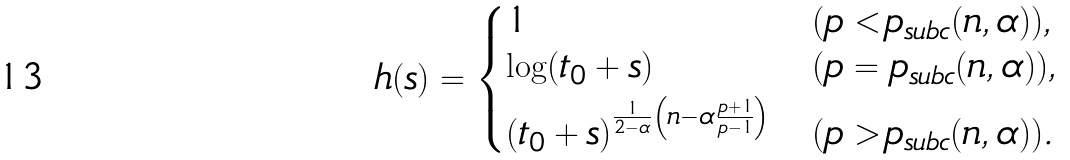Convert formula to latex. <formula><loc_0><loc_0><loc_500><loc_500>h ( s ) = \begin{dcases} 1 & ( p < p _ { s u b c } ( n , \alpha ) ) , \\ \log ( t _ { 0 } + s ) & ( p = p _ { s u b c } ( n , \alpha ) ) , \\ ( t _ { 0 } + s ) ^ { \frac { 1 } { 2 - \alpha } \left ( n - \alpha \frac { p + 1 } { p - 1 } \right ) } & ( p > p _ { s u b c } ( n , \alpha ) ) . \end{dcases}</formula> 